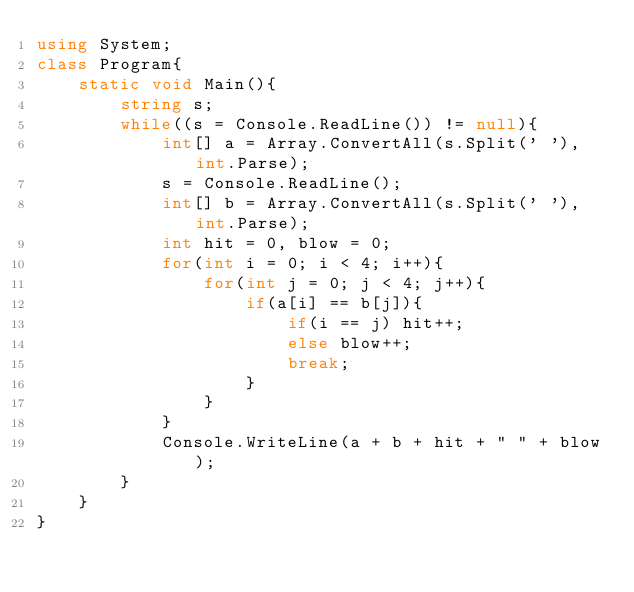Convert code to text. <code><loc_0><loc_0><loc_500><loc_500><_C#_>using System;
class Program{
	static void Main(){
		string s;
		while((s = Console.ReadLine()) != null){
			int[] a = Array.ConvertAll(s.Split(' '), int.Parse);
			s = Console.ReadLine();
			int[] b = Array.ConvertAll(s.Split(' '), int.Parse);
			int hit = 0, blow = 0;
			for(int i = 0; i < 4; i++){
				for(int j = 0; j < 4; j++){
					if(a[i] == b[j]){
						if(i == j) hit++;
						else blow++;
						break;
					}
				}
			}
			Console.WriteLine(a + b + hit + " " + blow);
		}
	}
}</code> 